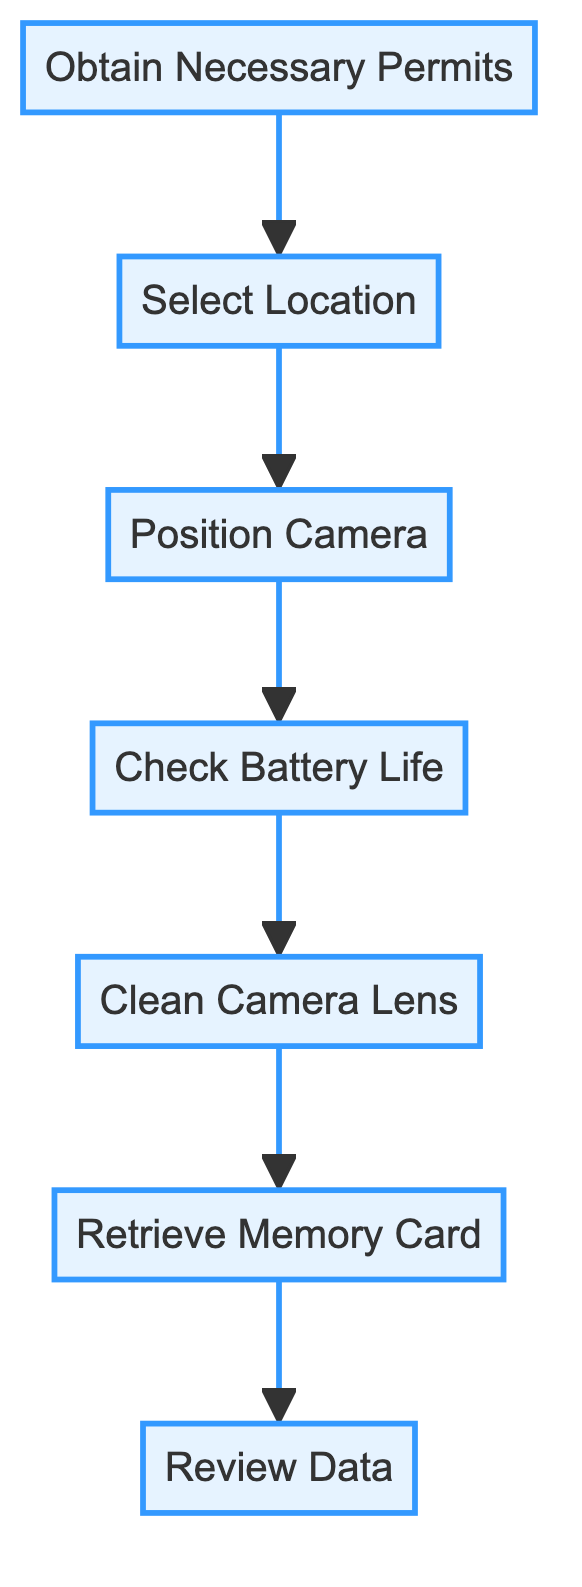What is the first step in the flowchart? The flowchart shows an ordered set of actions starting from "Obtain Necessary Permits," which is the first step located at the bottom of the diagram.
Answer: Obtain Necessary Permits How many steps are there in total? Counting all the distinct steps in the flowchart, there are seven steps: Obtain Necessary Permits, Select Location, Position Camera, Check Battery Life, Clean Camera Lens, Retrieve Memory Card, and Review Data.
Answer: Seven What step comes after "Check Battery Life"? Directly above "Check Battery Life" in the flowchart, the next step is "Clean Camera Lens," showing the sequence of actions required in wildlife camera setup and maintenance.
Answer: Clean Camera Lens Which two steps are directly linked? Reviewing the directed connections in the diagram, "Select Location" is linked directly to "Position Camera," indicating a sequential relationship where you select a location before positioning the camera.
Answer: Select Location, Position Camera Why is "Review Data" significant in the flowchart? "Review Data" is the last step in the sequence, which indicates that after all setup and maintenance actions are completed, analyzing the footage is crucial for assessing species and conservation strategies. Therefore, it signifies the data analysis phase of wildlife monitoring.
Answer: Data analysis phase What permits are necessary before setting up the wildlife camera? The flowchart indicates that securing permits from authorities like Parks Canada or British Columbia Ministry of Forests is the initial action needed to comply with conservation and research regulations prior to any camera setup activities.
Answer: Permits from authorities Which step follows "Retrieve Memory Card"? Looking closely at the diagram, after "Retrieve Memory Card," the next step is "Review Data," which follows the capture and retrieval process, leading into data analysis.
Answer: Review Data What step involves physical interaction with the camera? The actions that require direct physical handling or involvement with the camera include "Clean Camera Lens," "Check Battery Life," and "Retrieve Memory Card." These steps indicate maintenance tasks that ensure camera functionality.
Answer: Clean Camera Lens, Check Battery Life, Retrieve Memory Card 